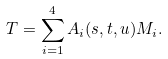Convert formula to latex. <formula><loc_0><loc_0><loc_500><loc_500>T = \sum _ { i = 1 } ^ { 4 } A _ { i } ( s , t , u ) M _ { i } .</formula> 